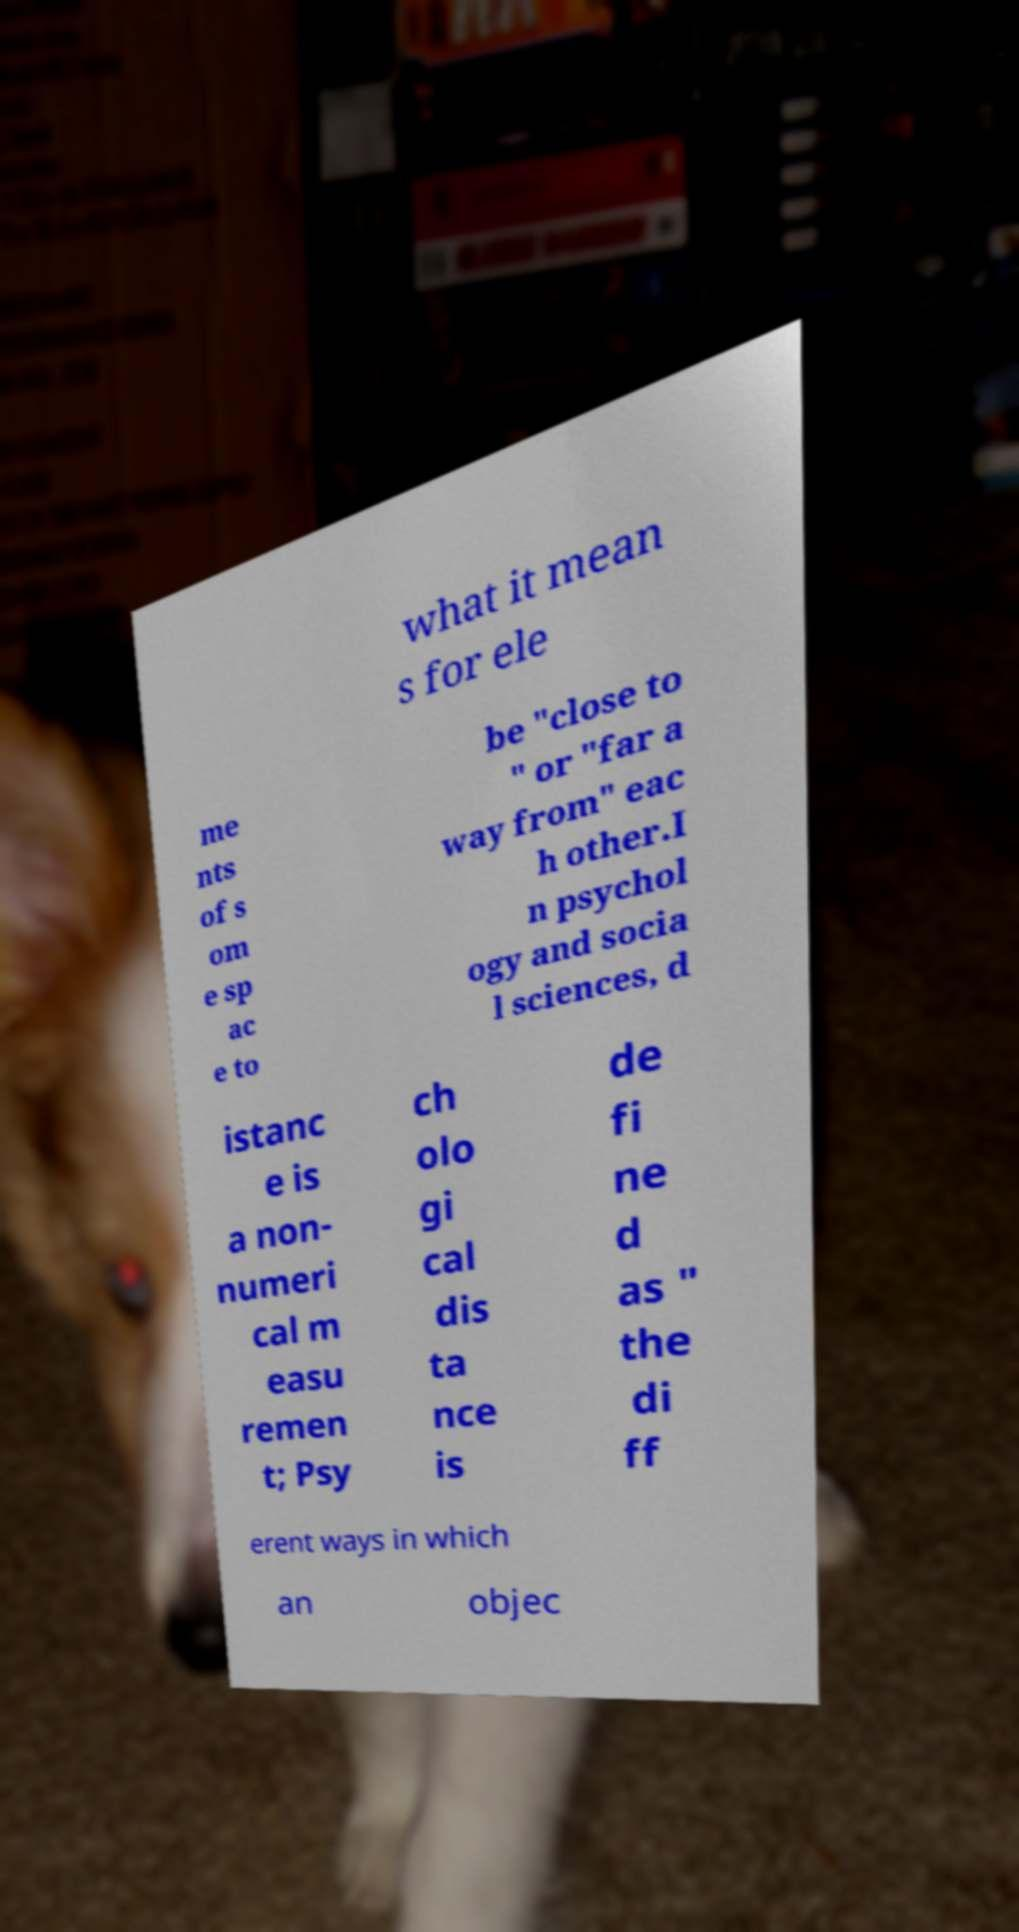Could you extract and type out the text from this image? what it mean s for ele me nts of s om e sp ac e to be "close to " or "far a way from" eac h other.I n psychol ogy and socia l sciences, d istanc e is a non- numeri cal m easu remen t; Psy ch olo gi cal dis ta nce is de fi ne d as " the di ff erent ways in which an objec 